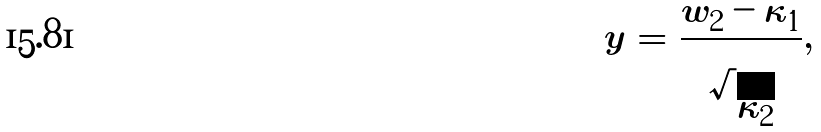<formula> <loc_0><loc_0><loc_500><loc_500>y = \frac { w _ { 2 } - \kappa _ { 1 } } { \sqrt { \kappa _ { 2 } } } ,</formula> 